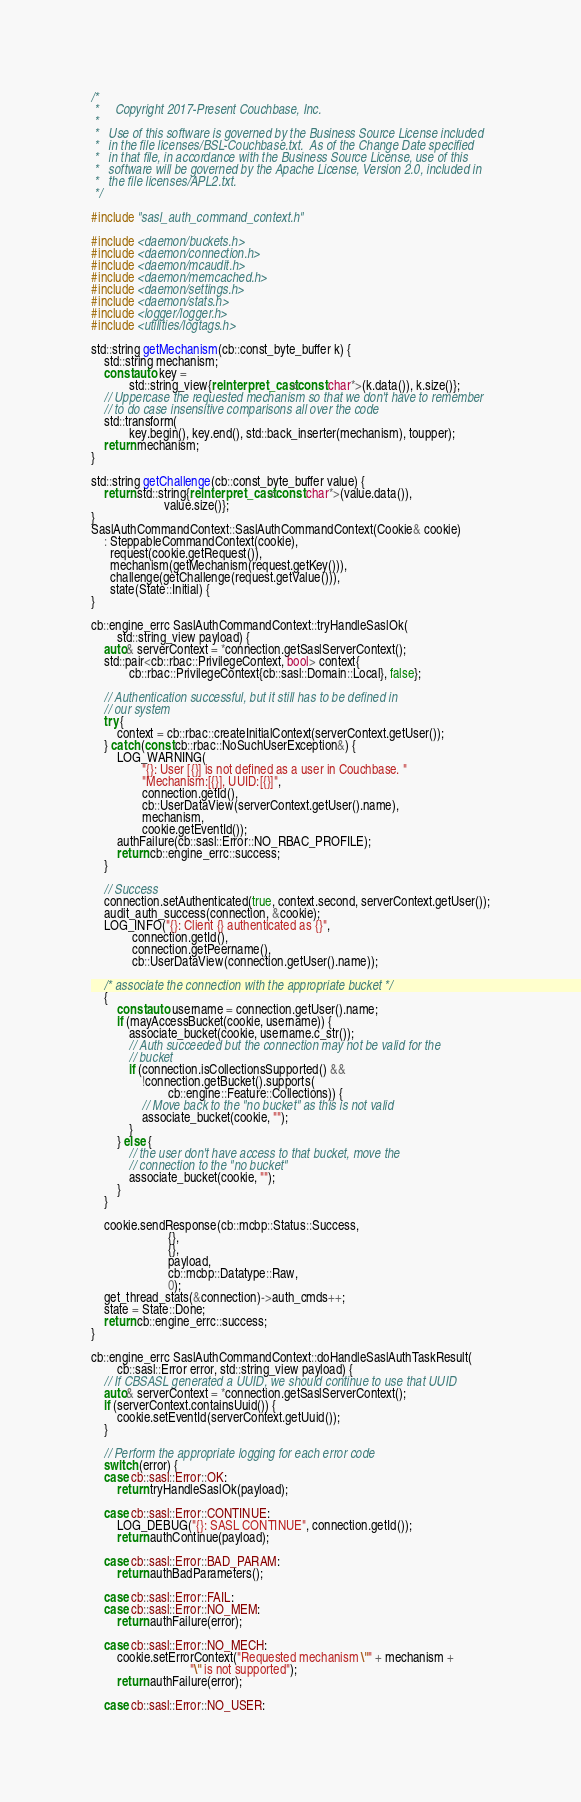Convert code to text. <code><loc_0><loc_0><loc_500><loc_500><_C++_>/*
 *     Copyright 2017-Present Couchbase, Inc.
 *
 *   Use of this software is governed by the Business Source License included
 *   in the file licenses/BSL-Couchbase.txt.  As of the Change Date specified
 *   in that file, in accordance with the Business Source License, use of this
 *   software will be governed by the Apache License, Version 2.0, included in
 *   the file licenses/APL2.txt.
 */

#include "sasl_auth_command_context.h"

#include <daemon/buckets.h>
#include <daemon/connection.h>
#include <daemon/mcaudit.h>
#include <daemon/memcached.h>
#include <daemon/settings.h>
#include <daemon/stats.h>
#include <logger/logger.h>
#include <utilities/logtags.h>

std::string getMechanism(cb::const_byte_buffer k) {
    std::string mechanism;
    const auto key =
            std::string_view{reinterpret_cast<const char*>(k.data()), k.size()};
    // Uppercase the requested mechanism so that we don't have to remember
    // to do case insensitive comparisons all over the code
    std::transform(
            key.begin(), key.end(), std::back_inserter(mechanism), toupper);
    return mechanism;
}

std::string getChallenge(cb::const_byte_buffer value) {
    return std::string{reinterpret_cast<const char*>(value.data()),
                       value.size()};
}
SaslAuthCommandContext::SaslAuthCommandContext(Cookie& cookie)
    : SteppableCommandContext(cookie),
      request(cookie.getRequest()),
      mechanism(getMechanism(request.getKey())),
      challenge(getChallenge(request.getValue())),
      state(State::Initial) {
}

cb::engine_errc SaslAuthCommandContext::tryHandleSaslOk(
        std::string_view payload) {
    auto& serverContext = *connection.getSaslServerContext();
    std::pair<cb::rbac::PrivilegeContext, bool> context{
            cb::rbac::PrivilegeContext{cb::sasl::Domain::Local}, false};

    // Authentication successful, but it still has to be defined in
    // our system
    try {
        context = cb::rbac::createInitialContext(serverContext.getUser());
    } catch (const cb::rbac::NoSuchUserException&) {
        LOG_WARNING(
                "{}: User [{}] is not defined as a user in Couchbase. "
                "Mechanism:[{}], UUID:[{}]",
                connection.getId(),
                cb::UserDataView(serverContext.getUser().name),
                mechanism,
                cookie.getEventId());
        authFailure(cb::sasl::Error::NO_RBAC_PROFILE);
        return cb::engine_errc::success;
    }

    // Success
    connection.setAuthenticated(true, context.second, serverContext.getUser());
    audit_auth_success(connection, &cookie);
    LOG_INFO("{}: Client {} authenticated as {}",
             connection.getId(),
             connection.getPeername(),
             cb::UserDataView(connection.getUser().name));

    /* associate the connection with the appropriate bucket */
    {
        const auto username = connection.getUser().name;
        if (mayAccessBucket(cookie, username)) {
            associate_bucket(cookie, username.c_str());
            // Auth succeeded but the connection may not be valid for the
            // bucket
            if (connection.isCollectionsSupported() &&
                !connection.getBucket().supports(
                        cb::engine::Feature::Collections)) {
                // Move back to the "no bucket" as this is not valid
                associate_bucket(cookie, "");
            }
        } else {
            // the user don't have access to that bucket, move the
            // connection to the "no bucket"
            associate_bucket(cookie, "");
        }
    }

    cookie.sendResponse(cb::mcbp::Status::Success,
                        {},
                        {},
                        payload,
                        cb::mcbp::Datatype::Raw,
                        0);
    get_thread_stats(&connection)->auth_cmds++;
    state = State::Done;
    return cb::engine_errc::success;
}

cb::engine_errc SaslAuthCommandContext::doHandleSaslAuthTaskResult(
        cb::sasl::Error error, std::string_view payload) {
    // If CBSASL generated a UUID, we should continue to use that UUID
    auto& serverContext = *connection.getSaslServerContext();
    if (serverContext.containsUuid()) {
        cookie.setEventId(serverContext.getUuid());
    }

    // Perform the appropriate logging for each error code
    switch (error) {
    case cb::sasl::Error::OK:
        return tryHandleSaslOk(payload);

    case cb::sasl::Error::CONTINUE:
        LOG_DEBUG("{}: SASL CONTINUE", connection.getId());
        return authContinue(payload);

    case cb::sasl::Error::BAD_PARAM:
        return authBadParameters();

    case cb::sasl::Error::FAIL:
    case cb::sasl::Error::NO_MEM:
        return authFailure(error);

    case cb::sasl::Error::NO_MECH:
        cookie.setErrorContext("Requested mechanism \"" + mechanism +
                               "\" is not supported");
        return authFailure(error);

    case cb::sasl::Error::NO_USER:</code> 